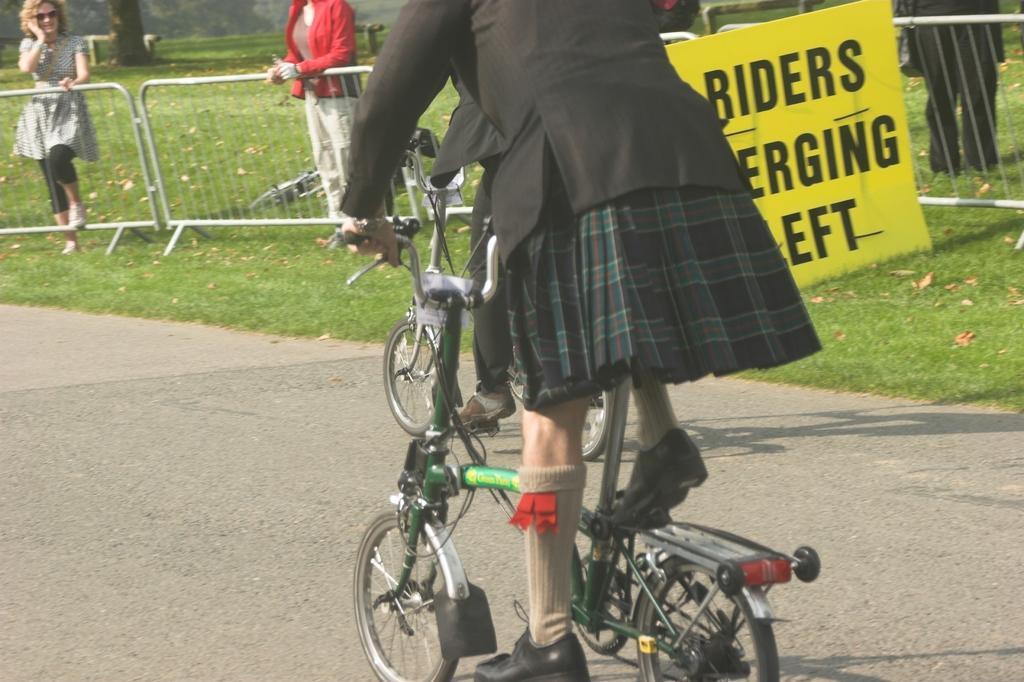How would you summarize this image in a sentence or two? In this image we can see a few people, two of them are riding bicycles on the road, there are leaves on the ground, we can see a board with some texts on it, there is a fencing, also we can see a tree trunk. 